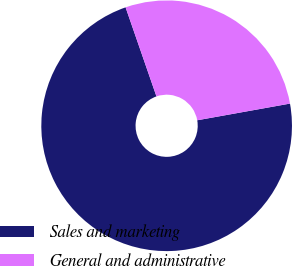<chart> <loc_0><loc_0><loc_500><loc_500><pie_chart><fcel>Sales and marketing<fcel>General and administrative<nl><fcel>72.52%<fcel>27.48%<nl></chart> 